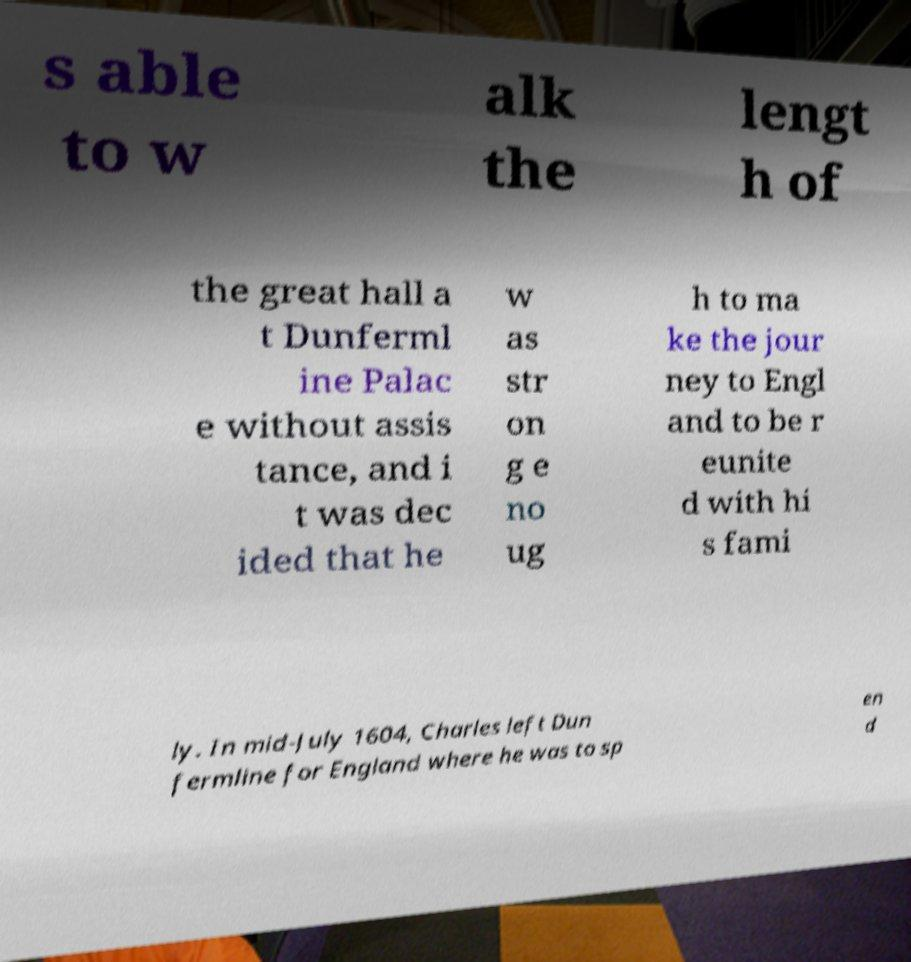Could you assist in decoding the text presented in this image and type it out clearly? s able to w alk the lengt h of the great hall a t Dunferml ine Palac e without assis tance, and i t was dec ided that he w as str on g e no ug h to ma ke the jour ney to Engl and to be r eunite d with hi s fami ly. In mid-July 1604, Charles left Dun fermline for England where he was to sp en d 